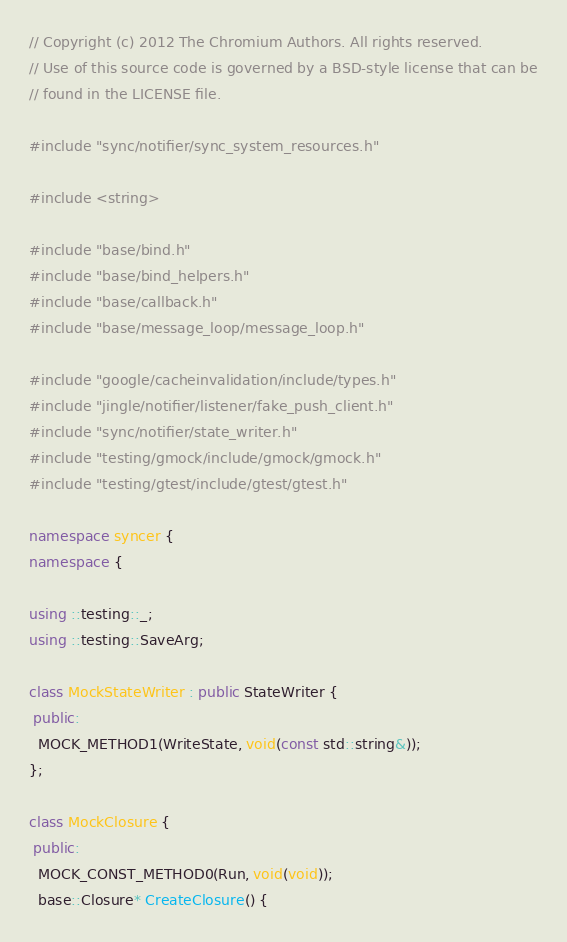<code> <loc_0><loc_0><loc_500><loc_500><_C++_>// Copyright (c) 2012 The Chromium Authors. All rights reserved.
// Use of this source code is governed by a BSD-style license that can be
// found in the LICENSE file.

#include "sync/notifier/sync_system_resources.h"

#include <string>

#include "base/bind.h"
#include "base/bind_helpers.h"
#include "base/callback.h"
#include "base/message_loop/message_loop.h"

#include "google/cacheinvalidation/include/types.h"
#include "jingle/notifier/listener/fake_push_client.h"
#include "sync/notifier/state_writer.h"
#include "testing/gmock/include/gmock/gmock.h"
#include "testing/gtest/include/gtest/gtest.h"

namespace syncer {
namespace {

using ::testing::_;
using ::testing::SaveArg;

class MockStateWriter : public StateWriter {
 public:
  MOCK_METHOD1(WriteState, void(const std::string&));
};

class MockClosure {
 public:
  MOCK_CONST_METHOD0(Run, void(void));
  base::Closure* CreateClosure() {</code> 